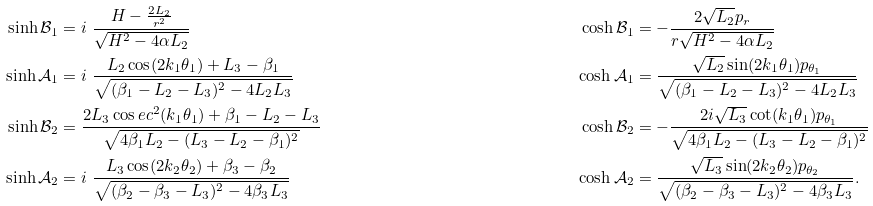Convert formula to latex. <formula><loc_0><loc_0><loc_500><loc_500>\sinh { \mathcal { B } } _ { 1 } & = i \ \frac { H - \frac { 2 L _ { 2 } } { r ^ { 2 } } } { \sqrt { H ^ { 2 } - 4 \alpha L _ { 2 } } } & \cosh { \mathcal { B } } _ { 1 } & = - \frac { 2 \sqrt { L _ { 2 } } p _ { r } } { r \sqrt { H ^ { 2 } - 4 \alpha L _ { 2 } } } \\ \sinh { \mathcal { A } } _ { 1 } & = i \ \frac { L _ { 2 } \cos ( 2 k _ { 1 } \theta _ { 1 } ) + L _ { 3 } - \beta _ { 1 } } { \sqrt { ( \beta _ { 1 } - L _ { 2 } - L _ { 3 } ) ^ { 2 } - 4 L _ { 2 } L _ { 3 } } } & \cosh { \mathcal { A } } _ { 1 } & = \frac { \sqrt { L _ { 2 } } \sin ( 2 k _ { 1 } \theta _ { 1 } ) p _ { \theta _ { 1 } } } { \sqrt { ( \beta _ { 1 } - L _ { 2 } - L _ { 3 } ) ^ { 2 } - 4 L _ { 2 } L _ { 3 } } } \\ \sinh { \mathcal { B } } _ { 2 } & = \frac { 2 L _ { 3 } \cos e c ^ { 2 } ( k _ { 1 } \theta _ { 1 } ) + \beta _ { 1 } - L _ { 2 } - L _ { 3 } } { \sqrt { 4 \beta _ { 1 } L _ { 2 } - ( L _ { 3 } - L _ { 2 } - \beta _ { 1 } ) ^ { 2 } } } & \cosh { \mathcal { B } } _ { 2 } & = - \frac { 2 i \sqrt { L _ { 3 } } \cot ( k _ { 1 } \theta _ { 1 } ) p _ { \theta _ { 1 } } } { \sqrt { 4 \beta _ { 1 } L _ { 2 } - ( L _ { 3 } - L _ { 2 } - \beta _ { 1 } ) ^ { 2 } } } \\ \sinh { \mathcal { A } } _ { 2 } & = i \ \frac { L _ { 3 } \cos ( 2 k _ { 2 } \theta _ { 2 } ) + \beta _ { 3 } - \beta _ { 2 } } { \sqrt { ( \beta _ { 2 } - \beta _ { 3 } - L _ { 3 } ) ^ { 2 } - 4 \beta _ { 3 } L _ { 3 } } } & \cosh { \mathcal { A } } _ { 2 } & = \frac { \sqrt { L _ { 3 } } \sin ( 2 k _ { 2 } \theta _ { 2 } ) p _ { \theta _ { 2 } } } { \sqrt { ( \beta _ { 2 } - \beta _ { 3 } - L _ { 3 } ) ^ { 2 } - 4 \beta _ { 3 } L _ { 3 } } } .</formula> 